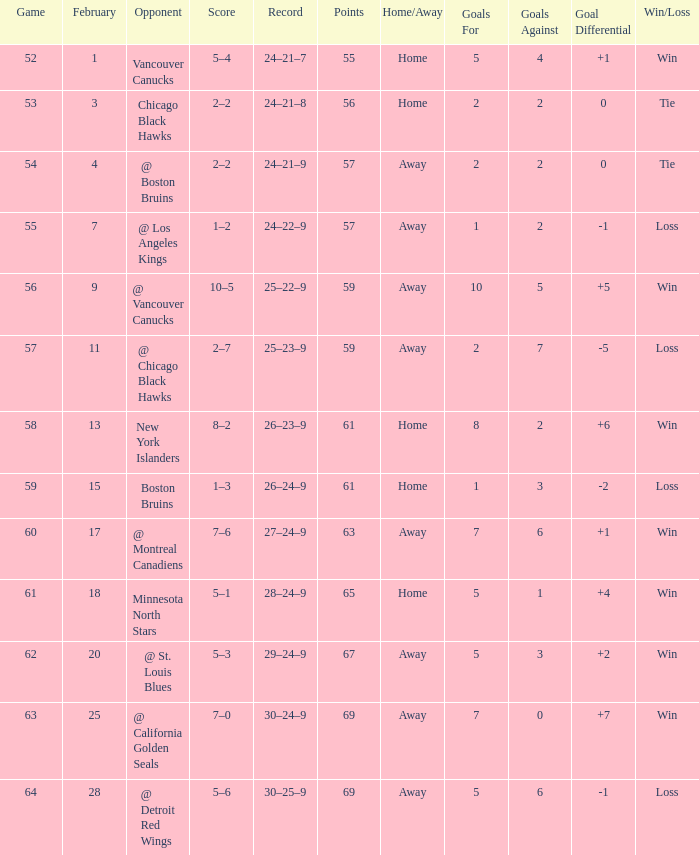Which opponent has a game larger than 61, february smaller than 28, and fewer points than 69? @ St. Louis Blues. 